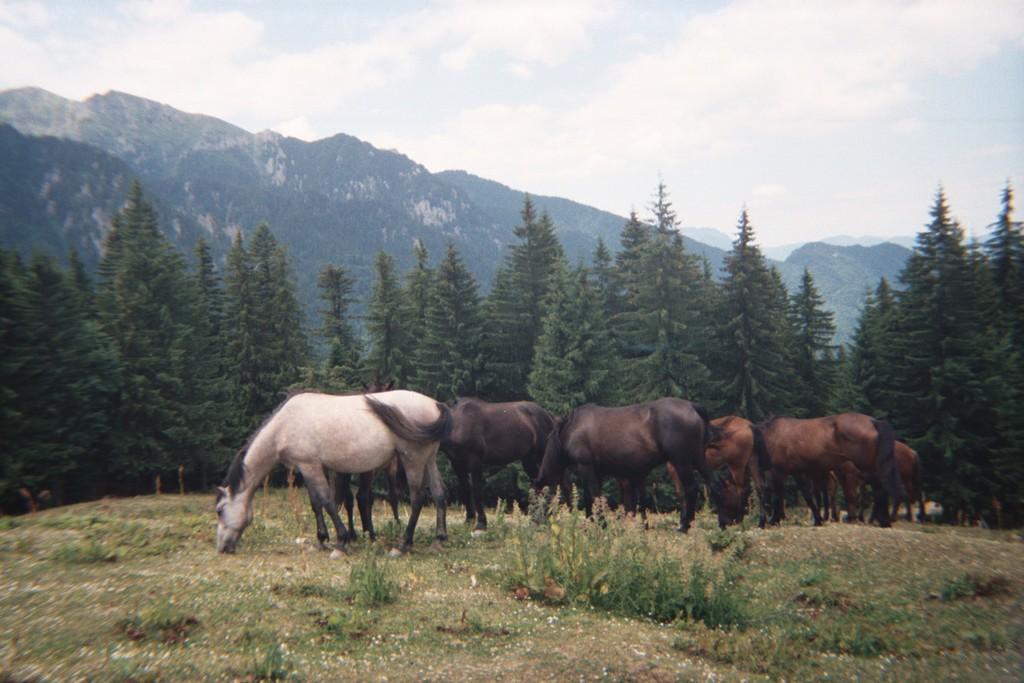Could you give a brief overview of what you see in this image? In this image, we can see some animals. We can see the ground. We can see some grass, plants, hills and trees. We can also see the sky with clouds. 